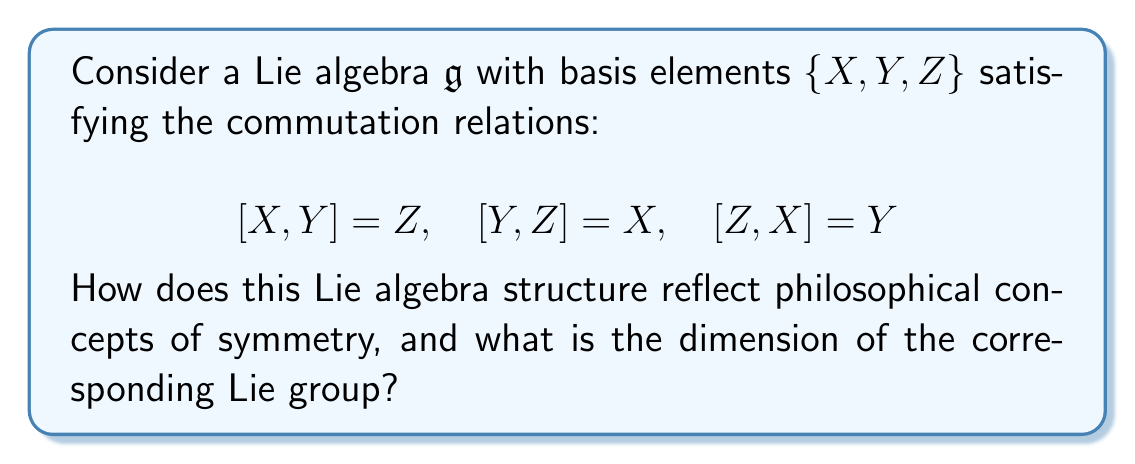Show me your answer to this math problem. This question connects Lie algebras to philosophical concepts of symmetry, which aligns with the given persona's interest in philosophical debates and skepticism towards purely theoretical constructs.

1. Symmetry in philosophy often refers to the invariance of an object or system under certain transformations. In this case, the Lie algebra $\mathfrak{g}$ represents infinitesimal symmetry transformations.

2. The commutation relations given define a specific structure known as $\mathfrak{so}(3)$, the Lie algebra of the Special Orthogonal group SO(3). This group describes rotations in three-dimensional space, which is a fundamental symmetry in nature.

3. The cyclic nature of the commutation relations ($[X, Y] = Z$, $[Y, Z] = X$, $[Z, X] = Y$) reflects a philosophical concept of balance and interchangeability. Each element can be viewed as both a result of and a contributor to the others' interactions.

4. The dimension of a Lie algebra is equal to the dimension of its corresponding Lie group. In this case, we can count the number of basis elements to determine the dimension.

5. The basis $\{X, Y, Z\}$ consists of three elements, each representing an independent direction of infinitesimal rotation in 3D space.

Therefore, the dimension of the corresponding Lie group (SO(3)) is 3. This reflects the three degrees of freedom in 3D rotations, which can be philosophically interpreted as the minimal set of parameters needed to fully describe the symmetry of rotations in our physical space.
Answer: The dimension of the corresponding Lie group is 3. 